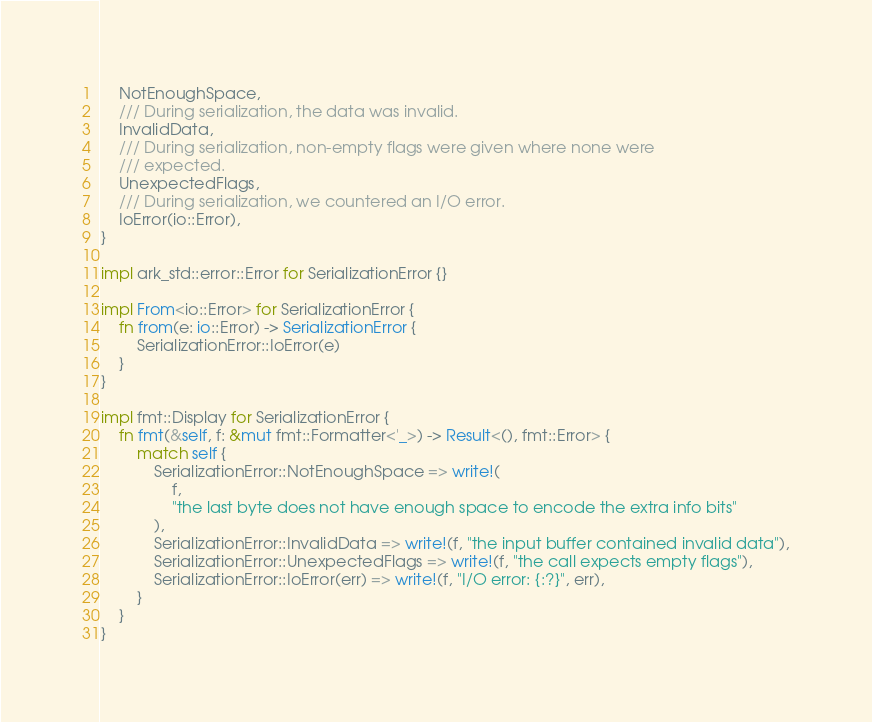Convert code to text. <code><loc_0><loc_0><loc_500><loc_500><_Rust_>    NotEnoughSpace,
    /// During serialization, the data was invalid.
    InvalidData,
    /// During serialization, non-empty flags were given where none were
    /// expected.
    UnexpectedFlags,
    /// During serialization, we countered an I/O error.
    IoError(io::Error),
}

impl ark_std::error::Error for SerializationError {}

impl From<io::Error> for SerializationError {
    fn from(e: io::Error) -> SerializationError {
        SerializationError::IoError(e)
    }
}

impl fmt::Display for SerializationError {
    fn fmt(&self, f: &mut fmt::Formatter<'_>) -> Result<(), fmt::Error> {
        match self {
            SerializationError::NotEnoughSpace => write!(
                f,
                "the last byte does not have enough space to encode the extra info bits"
            ),
            SerializationError::InvalidData => write!(f, "the input buffer contained invalid data"),
            SerializationError::UnexpectedFlags => write!(f, "the call expects empty flags"),
            SerializationError::IoError(err) => write!(f, "I/O error: {:?}", err),
        }
    }
}
</code> 